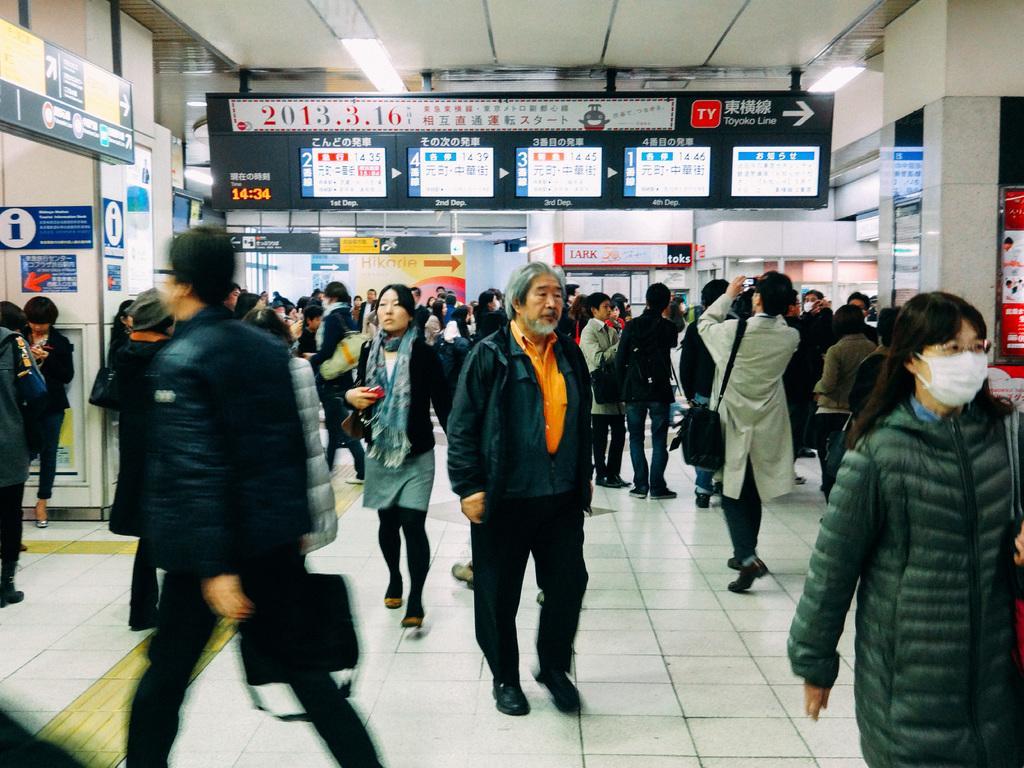How would you summarize this image in a sentence or two? In this image there are few people standing on the floor, while some people are walking. At the top there is ceiling with the lights. In the middle there is a directional board. On the left side there is a board on which there is an arrow mark. At the bottom there are pillars on which there are stickers. 